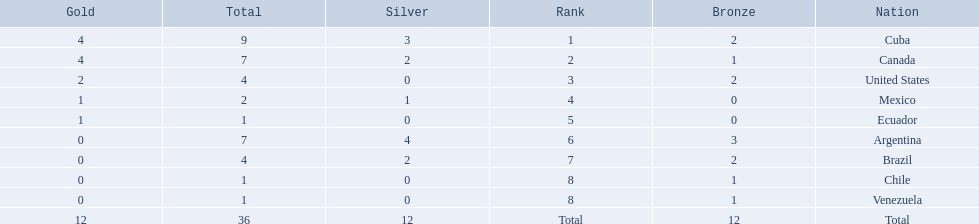What countries participated? Cuba, 4, 3, 2, Canada, 4, 2, 1, United States, 2, 0, 2, Mexico, 1, 1, 0, Ecuador, 1, 0, 0, Argentina, 0, 4, 3, Brazil, 0, 2, 2, Chile, 0, 0, 1, Venezuela, 0, 0, 1. What countries won 1 gold Mexico, 1, 1, 0, Ecuador, 1, 0, 0. Parse the full table in json format. {'header': ['Gold', 'Total', 'Silver', 'Rank', 'Bronze', 'Nation'], 'rows': [['4', '9', '3', '1', '2', 'Cuba'], ['4', '7', '2', '2', '1', 'Canada'], ['2', '4', '0', '3', '2', 'United States'], ['1', '2', '1', '4', '0', 'Mexico'], ['1', '1', '0', '5', '0', 'Ecuador'], ['0', '7', '4', '6', '3', 'Argentina'], ['0', '4', '2', '7', '2', 'Brazil'], ['0', '1', '0', '8', '1', 'Chile'], ['0', '1', '0', '8', '1', 'Venezuela'], ['12', '36', '12', 'Total', '12', 'Total']]} What country above also won no silver? Ecuador. What were all of the nations involved in the canoeing at the 2011 pan american games? Cuba, Canada, United States, Mexico, Ecuador, Argentina, Brazil, Chile, Venezuela, Total. Of these, which had a numbered rank? Cuba, Canada, United States, Mexico, Ecuador, Argentina, Brazil, Chile, Venezuela. From these, which had the highest number of bronze? Argentina. 